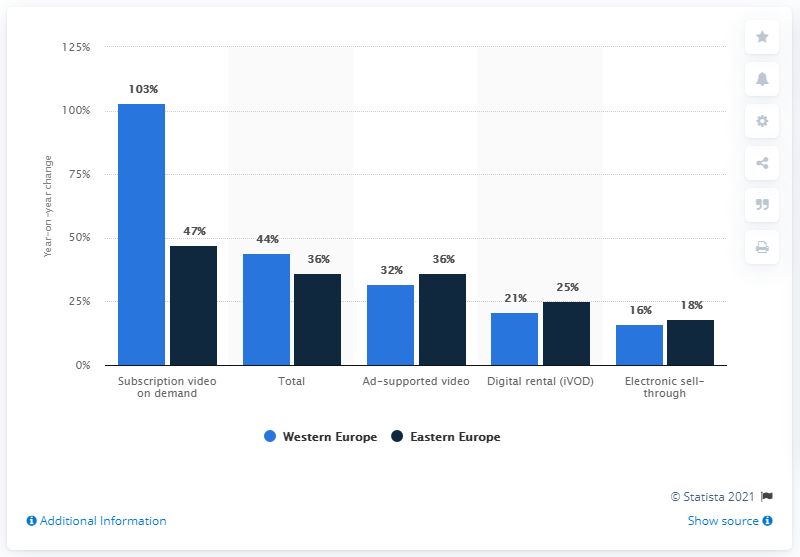Indicate a few pertinent items in this graphic. Strategy Analytics predicted that subscription video on demand revenue would increase by 47% in 2014. The largest value of navy blue bar is 47. The difference between the highest and lowest temperatures in Western Europe is 87 degrees. 